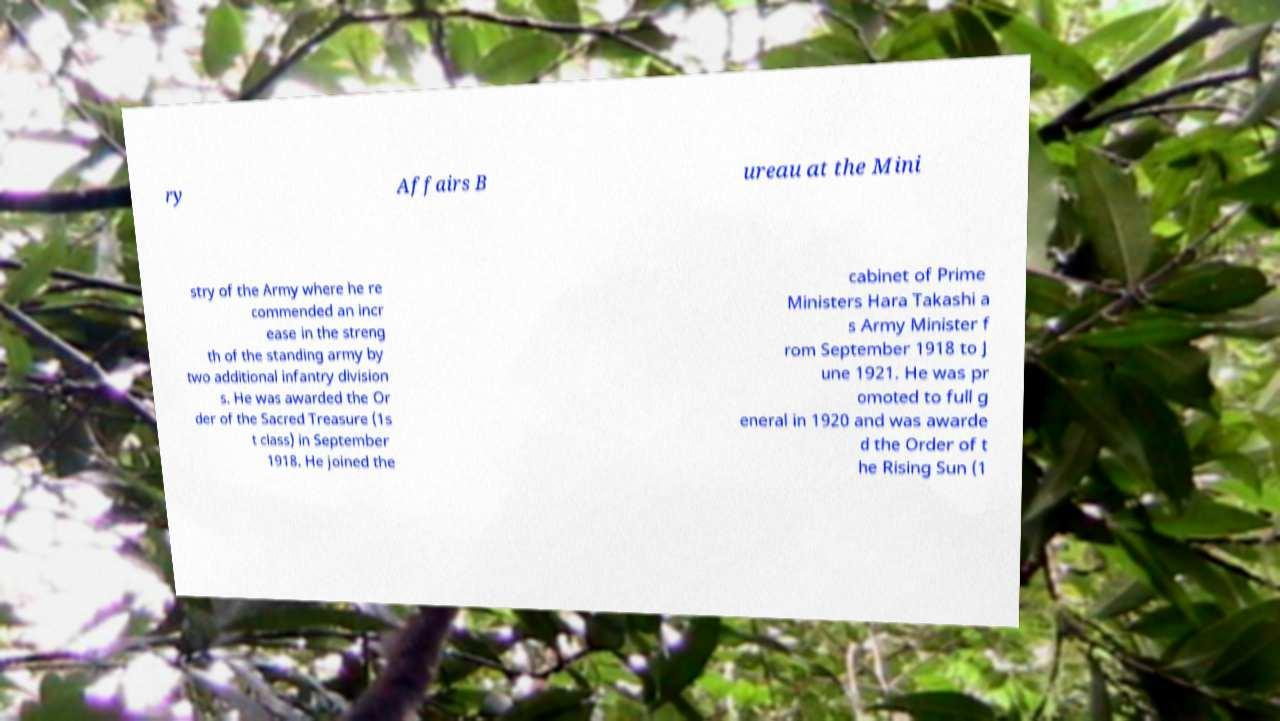What messages or text are displayed in this image? I need them in a readable, typed format. ry Affairs B ureau at the Mini stry of the Army where he re commended an incr ease in the streng th of the standing army by two additional infantry division s. He was awarded the Or der of the Sacred Treasure (1s t class) in September 1918. He joined the cabinet of Prime Ministers Hara Takashi a s Army Minister f rom September 1918 to J une 1921. He was pr omoted to full g eneral in 1920 and was awarde d the Order of t he Rising Sun (1 